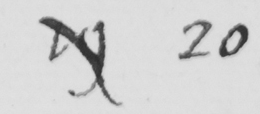What text is written in this handwritten line? 19 20 